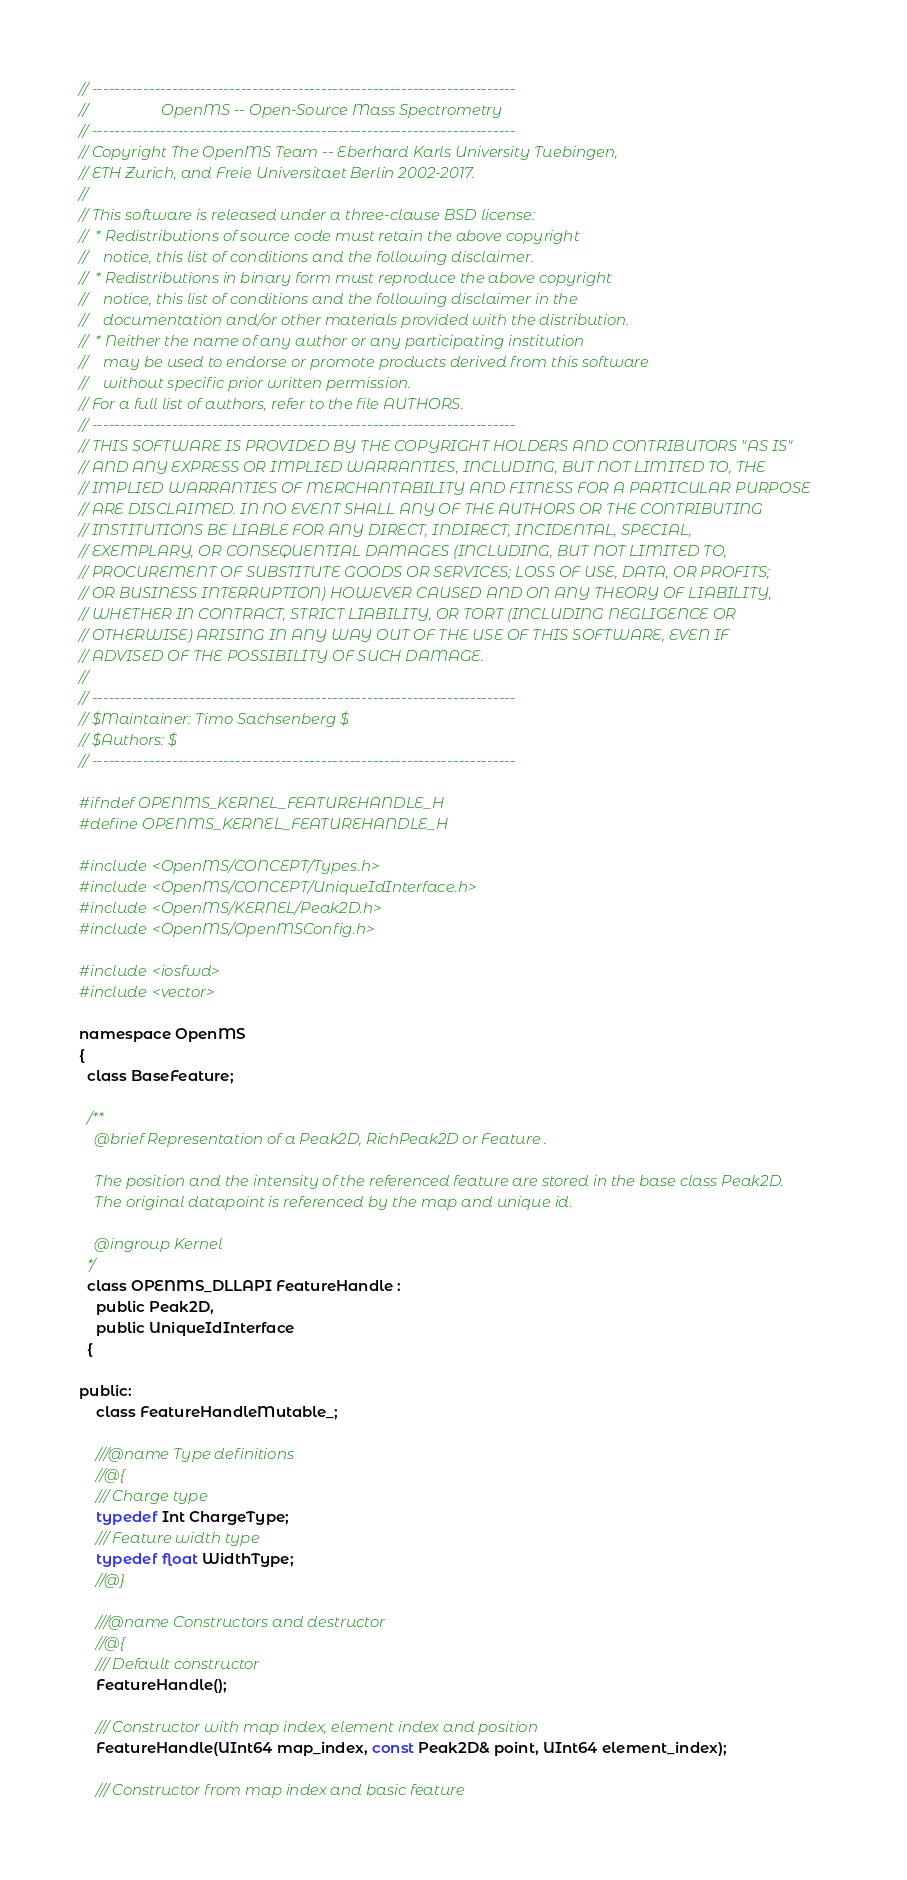Convert code to text. <code><loc_0><loc_0><loc_500><loc_500><_C_>// --------------------------------------------------------------------------
//                   OpenMS -- Open-Source Mass Spectrometry
// --------------------------------------------------------------------------
// Copyright The OpenMS Team -- Eberhard Karls University Tuebingen,
// ETH Zurich, and Freie Universitaet Berlin 2002-2017.
//
// This software is released under a three-clause BSD license:
//  * Redistributions of source code must retain the above copyright
//    notice, this list of conditions and the following disclaimer.
//  * Redistributions in binary form must reproduce the above copyright
//    notice, this list of conditions and the following disclaimer in the
//    documentation and/or other materials provided with the distribution.
//  * Neither the name of any author or any participating institution
//    may be used to endorse or promote products derived from this software
//    without specific prior written permission.
// For a full list of authors, refer to the file AUTHORS.
// --------------------------------------------------------------------------
// THIS SOFTWARE IS PROVIDED BY THE COPYRIGHT HOLDERS AND CONTRIBUTORS "AS IS"
// AND ANY EXPRESS OR IMPLIED WARRANTIES, INCLUDING, BUT NOT LIMITED TO, THE
// IMPLIED WARRANTIES OF MERCHANTABILITY AND FITNESS FOR A PARTICULAR PURPOSE
// ARE DISCLAIMED. IN NO EVENT SHALL ANY OF THE AUTHORS OR THE CONTRIBUTING
// INSTITUTIONS BE LIABLE FOR ANY DIRECT, INDIRECT, INCIDENTAL, SPECIAL,
// EXEMPLARY, OR CONSEQUENTIAL DAMAGES (INCLUDING, BUT NOT LIMITED TO,
// PROCUREMENT OF SUBSTITUTE GOODS OR SERVICES; LOSS OF USE, DATA, OR PROFITS;
// OR BUSINESS INTERRUPTION) HOWEVER CAUSED AND ON ANY THEORY OF LIABILITY,
// WHETHER IN CONTRACT, STRICT LIABILITY, OR TORT (INCLUDING NEGLIGENCE OR
// OTHERWISE) ARISING IN ANY WAY OUT OF THE USE OF THIS SOFTWARE, EVEN IF
// ADVISED OF THE POSSIBILITY OF SUCH DAMAGE.
//
// --------------------------------------------------------------------------
// $Maintainer: Timo Sachsenberg $
// $Authors: $
// --------------------------------------------------------------------------

#ifndef OPENMS_KERNEL_FEATUREHANDLE_H
#define OPENMS_KERNEL_FEATUREHANDLE_H

#include <OpenMS/CONCEPT/Types.h>
#include <OpenMS/CONCEPT/UniqueIdInterface.h>
#include <OpenMS/KERNEL/Peak2D.h>
#include <OpenMS/OpenMSConfig.h>

#include <iosfwd>
#include <vector>

namespace OpenMS
{
  class BaseFeature;

  /**
    @brief Representation of a Peak2D, RichPeak2D or Feature .

    The position and the intensity of the referenced feature are stored in the base class Peak2D.
    The original datapoint is referenced by the map and unique id.

    @ingroup Kernel
  */
  class OPENMS_DLLAPI FeatureHandle :
    public Peak2D,
    public UniqueIdInterface
  {

public:
    class FeatureHandleMutable_;

    ///@name Type definitions
    //@{
    /// Charge type
    typedef Int ChargeType;
    /// Feature width type
    typedef float WidthType;
    //@}

    ///@name Constructors and destructor
    //@{
    /// Default constructor
    FeatureHandle();

    /// Constructor with map index, element index and position
    FeatureHandle(UInt64 map_index, const Peak2D& point, UInt64 element_index);

    /// Constructor from map index and basic feature</code> 